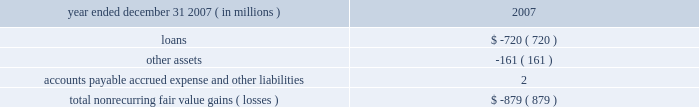Jpmorgan chase & co .
/ 2007 annual report 117 nonrecurring fair value changes the table presents the total change in value of financial instruments for which a fair value adjustment has been included in the consolidated statement of income for the year ended december 31 , 2007 , related to financial instruments held at december 31 , 2007 .
Year ended december 31 , 2007 ( in millions ) 2007 .
In the above table , loans principally include changes in fair value for loans carried on the balance sheet at the lower of cost or fair value ; and accounts payable , accrued expense and other liabilities principally includes the change in fair value for unfunded lending-related commitments within the leveraged lending portfolio .
Level 3 assets analysis level 3 assets ( including assets measured at the lower of cost or fair value ) were 5% ( 5 % ) of total firm assets at december 31 , 2007 .
These assets increased during 2007 principally during the second half of the year , when liquidity in mortgages and other credit products fell dra- matically .
The increase was primarily due to an increase in leveraged loan balances within level 3 as the ability of the firm to syndicate this risk to third parties became limited by the credit environment .
In addi- tion , there were transfers from level 2 to level 3 during 2007 .
These transfers were principally for instruments within the mortgage market where inputs which are significant to their valuation became unob- servable during the year .
Subprime and alt-a whole loans , subprime home equity securities , commercial mortgage-backed mezzanine loans and credit default swaps referenced to asset-backed securities consti- tuted the majority of the affected instruments , reflecting a significant decline in liquidity in these instruments in the third and fourth quarters of 2007 , as new issue activity was nonexistent and independent pric- ing information was no longer available for these assets .
Transition in connection with the initial adoption of sfas 157 , the firm recorded the following on january 1 , 2007 : 2022 a cumulative effect increase to retained earnings of $ 287 million , primarily related to the release of profit previously deferred in accordance with eitf 02-3 ; 2022 an increase to pretax income of $ 166 million ( $ 103 million after-tax ) related to the incorporation of the firm 2019s creditworthiness in the valuation of liabilities recorded at fair value ; and 2022 an increase to pretax income of $ 464 million ( $ 288 million after-tax ) related to valuations of nonpublic private equity investments .
Prior to the adoption of sfas 157 , the firm applied the provisions of eitf 02-3 to its derivative portfolio .
Eitf 02-3 precluded the recogni- tion of initial trading profit in the absence of : ( a ) quoted market prices , ( b ) observable prices of other current market transactions or ( c ) other observable data supporting a valuation technique .
In accor- dance with eitf 02-3 , the firm recognized the deferred profit in principal transactions revenue on a systematic basis ( typically straight- line amortization over the life of the instruments ) and when observ- able market data became available .
Prior to the adoption of sfas 157 the firm did not incorporate an adjustment into the valuation of liabilities carried at fair value on the consolidated balance sheet .
Commencing january 1 , 2007 , in accor- dance with the requirements of sfas 157 , an adjustment was made to the valuation of liabilities measured at fair value to reflect the credit quality of the firm .
Prior to the adoption of sfas 157 , privately held investments were initially valued based upon cost .
The carrying values of privately held investments were adjusted from cost to reflect both positive and neg- ative changes evidenced by financing events with third-party capital providers .
The investments were also subject to ongoing impairment reviews by private equity senior investment professionals .
The increase in pretax income related to nonpublic private equity investments in connection with the adoption of sfas 157 was due to there being sufficient market evidence to support an increase in fair values using the sfas 157 methodology , although there had not been an actual third-party market transaction related to such investments .
Financial disclosures required by sfas 107 sfas 107 requires disclosure of the estimated fair value of certain financial instruments and the methods and significant assumptions used to estimate their fair values .
Many but not all of the financial instruments held by the firm are recorded at fair value on the consolidated balance sheets .
Financial instruments within the scope of sfas 107 that are not carried at fair value on the consolidated balance sheets are discussed below .
Additionally , certain financial instruments and all nonfinancial instruments are excluded from the scope of sfas 107 .
Accordingly , the fair value disclosures required by sfas 107 provide only a partial estimate of the fair value of jpmorgan chase .
For example , the firm has developed long-term relationships with its customers through its deposit base and credit card accounts , commonly referred to as core deposit intangibles and credit card relationships .
In the opinion of management , these items , in the aggregate , add significant value to jpmorgan chase , but their fair value is not disclosed in this note .
Financial instruments for which fair value approximates carrying value certain financial instruments that are not carried at fair value on the consolidated balance sheets are carried at amounts that approxi- mate fair value due to their short-term nature and generally negligi- ble credit risk .
These instruments include cash and due from banks , deposits with banks , federal funds sold , securities purchased under resale agreements with short-dated maturities , securities borrowed , short-term receivables and accrued interest receivable , commercial paper , federal funds purchased , securities sold under repurchase agreements with short-dated maturities , other borrowed funds , accounts payable and accrued liabilities .
In addition , sfas 107 requires that the fair value for deposit liabilities with no stated matu- rity ( i.e. , demand , savings and certain money market deposits ) be equal to their carrying value .
Sfas 107 does not allow for the recog- nition of the inherent funding value of these instruments. .
For 2007 , what was the net income effect ( in millions ) of the sfas 157 transition adjustments? 
Computations: (166 + 464)
Answer: 630.0. 